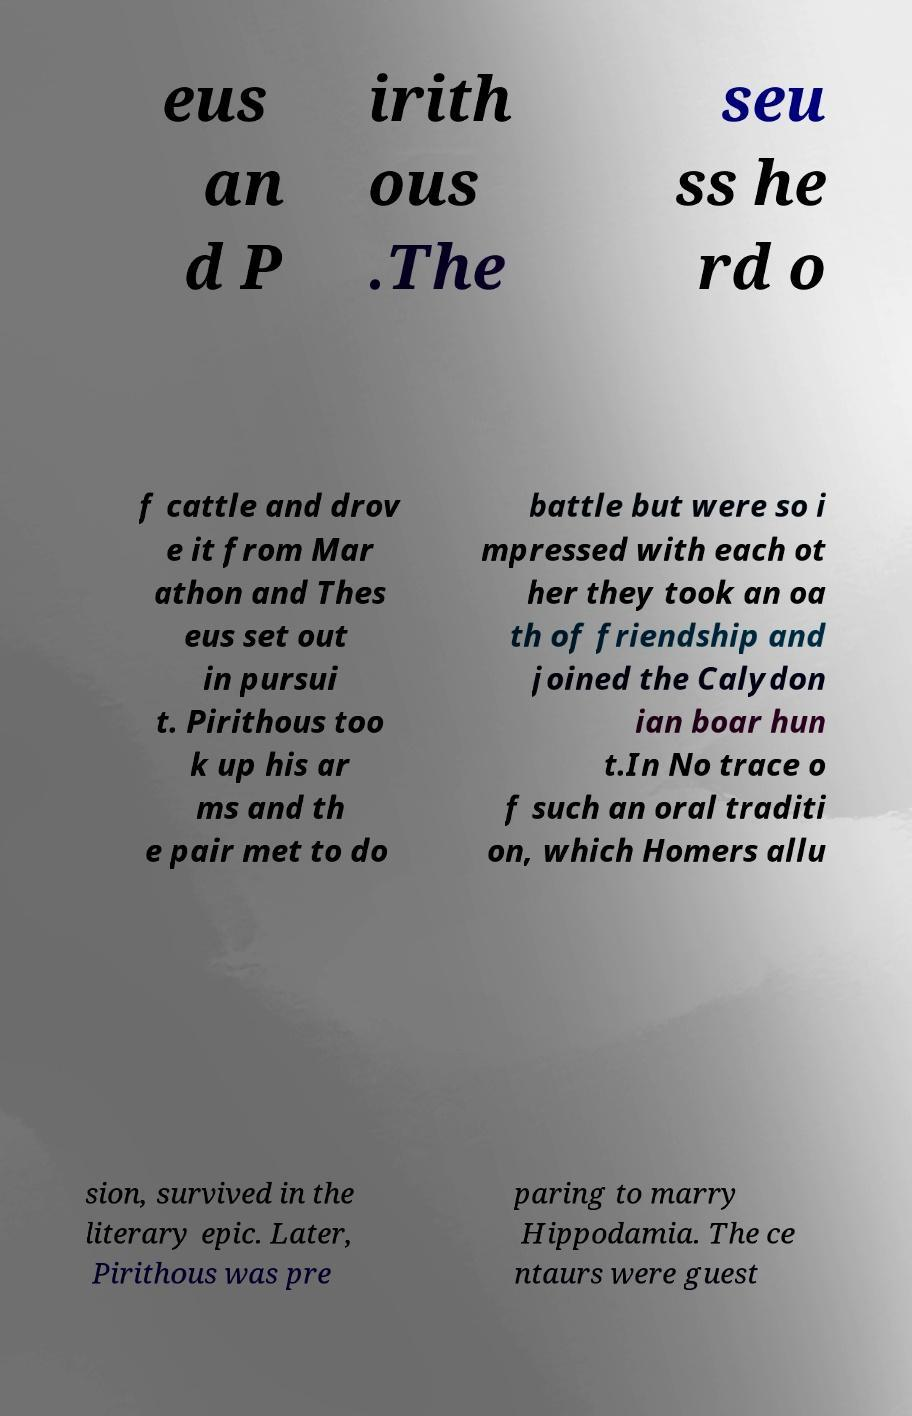Please identify and transcribe the text found in this image. eus an d P irith ous .The seu ss he rd o f cattle and drov e it from Mar athon and Thes eus set out in pursui t. Pirithous too k up his ar ms and th e pair met to do battle but were so i mpressed with each ot her they took an oa th of friendship and joined the Calydon ian boar hun t.In No trace o f such an oral traditi on, which Homers allu sion, survived in the literary epic. Later, Pirithous was pre paring to marry Hippodamia. The ce ntaurs were guest 